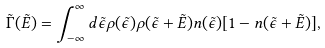<formula> <loc_0><loc_0><loc_500><loc_500>\tilde { \Gamma } ( \tilde { E } ) = \int _ { - \infty } ^ { \infty } d \tilde { \epsilon } \rho ( { \tilde { \epsilon } } ) \rho ( { \tilde { \epsilon } } + \tilde { E } ) n ( { \tilde { \epsilon } } ) [ 1 - n ( { \tilde { \epsilon } } + \tilde { E } ) ] ,</formula> 